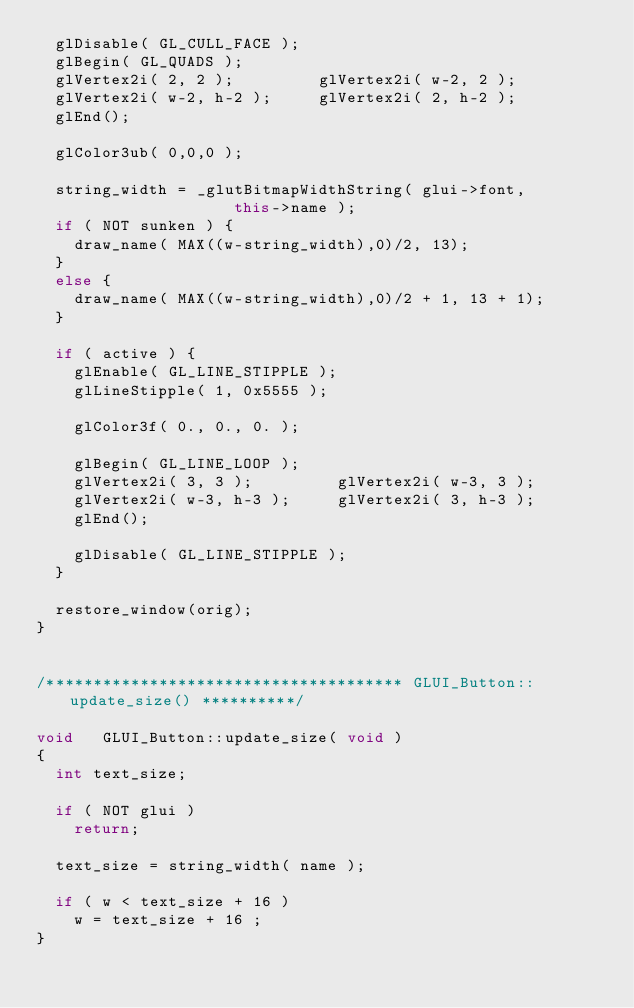Convert code to text. <code><loc_0><loc_0><loc_500><loc_500><_C++_>  glDisable( GL_CULL_FACE );
  glBegin( GL_QUADS );
  glVertex2i( 2, 2 );         glVertex2i( w-2, 2 );
  glVertex2i( w-2, h-2 );     glVertex2i( 2, h-2 );
  glEnd();

  glColor3ub( 0,0,0 );
  
  string_width = _glutBitmapWidthString( glui->font,
                     this->name );
  if ( NOT sunken ) {
    draw_name( MAX((w-string_width),0)/2, 13);
  }
  else {
    draw_name( MAX((w-string_width),0)/2 + 1, 13 + 1);
  }

  if ( active ) {
    glEnable( GL_LINE_STIPPLE );
    glLineStipple( 1, 0x5555 );
    
    glColor3f( 0., 0., 0. );
    
    glBegin( GL_LINE_LOOP );
    glVertex2i( 3, 3 );         glVertex2i( w-3, 3 );
    glVertex2i( w-3, h-3 );     glVertex2i( 3, h-3 );
    glEnd();
    
    glDisable( GL_LINE_STIPPLE );
  }

  restore_window(orig);
}


/************************************** GLUI_Button::update_size() **********/

void   GLUI_Button::update_size( void )
{
  int text_size;

  if ( NOT glui )
    return;

  text_size = string_width( name );

  if ( w < text_size + 16 )
    w = text_size + 16 ;
}
</code> 